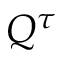<formula> <loc_0><loc_0><loc_500><loc_500>Q ^ { \tau }</formula> 